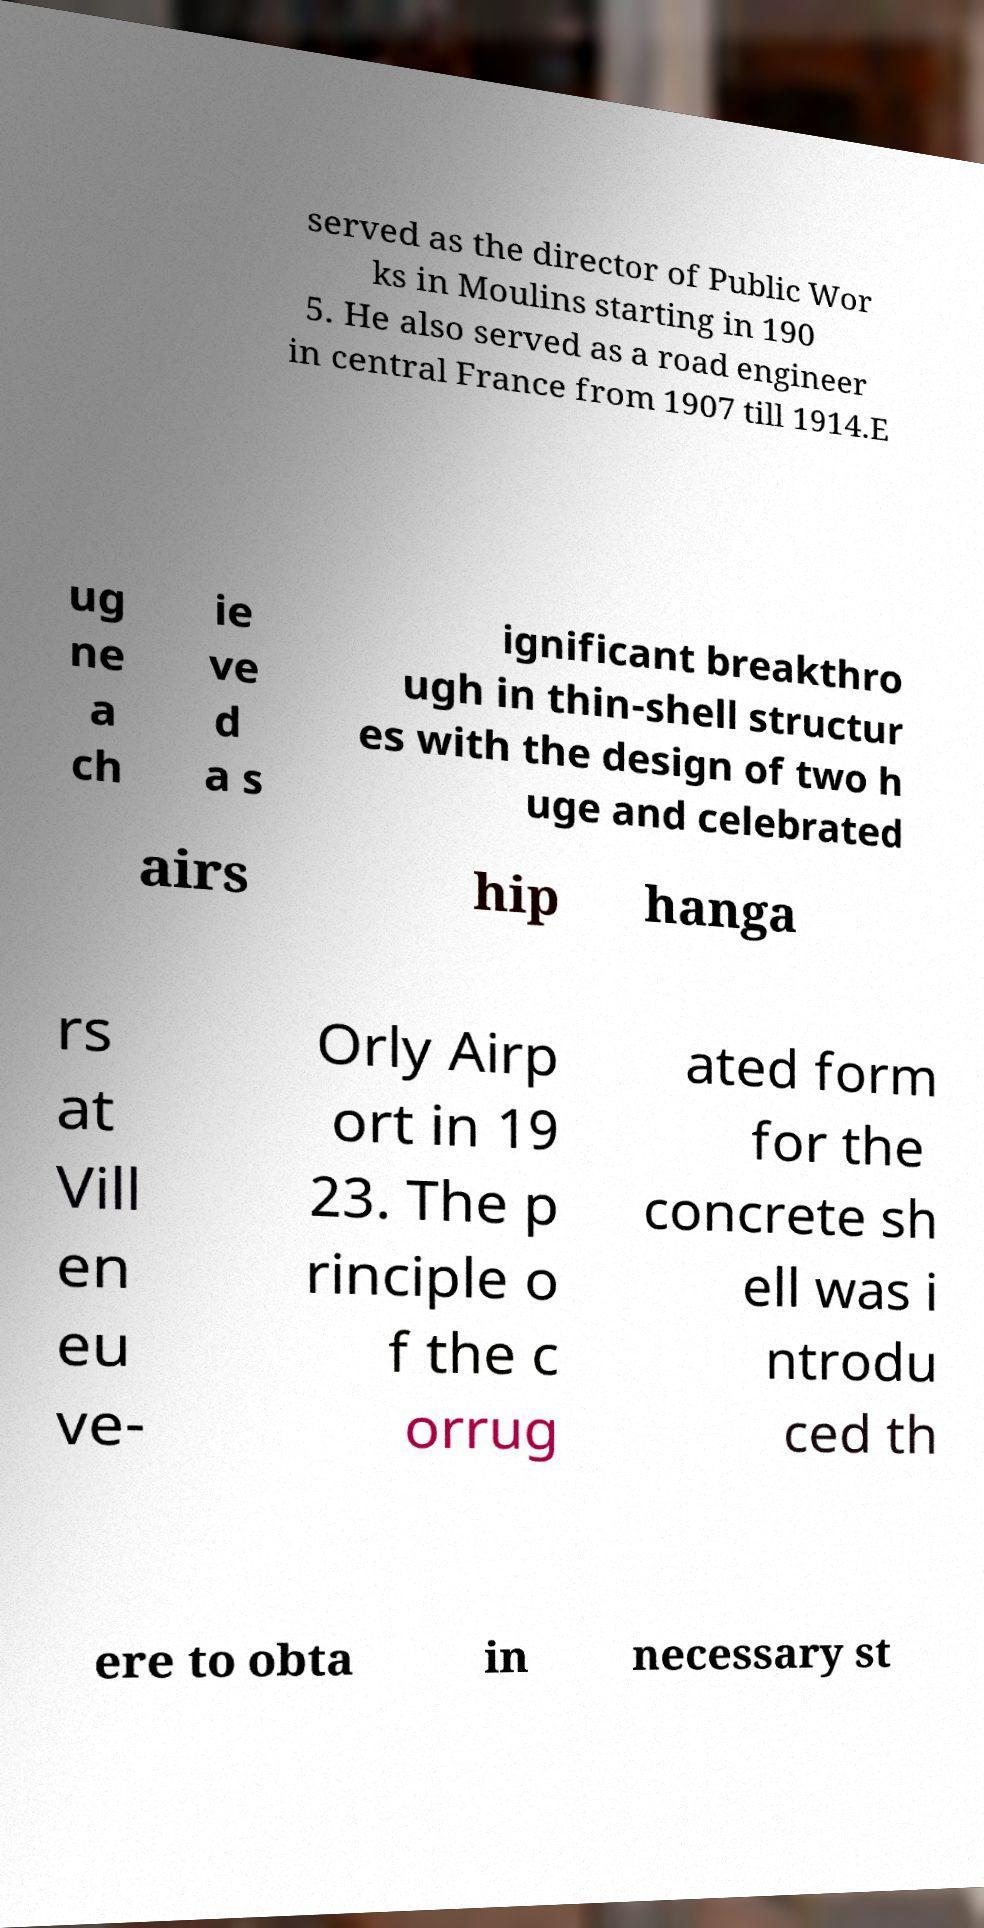What messages or text are displayed in this image? I need them in a readable, typed format. served as the director of Public Wor ks in Moulins starting in 190 5. He also served as a road engineer in central France from 1907 till 1914.E ug ne a ch ie ve d a s ignificant breakthro ugh in thin-shell structur es with the design of two h uge and celebrated airs hip hanga rs at Vill en eu ve- Orly Airp ort in 19 23. The p rinciple o f the c orrug ated form for the concrete sh ell was i ntrodu ced th ere to obta in necessary st 